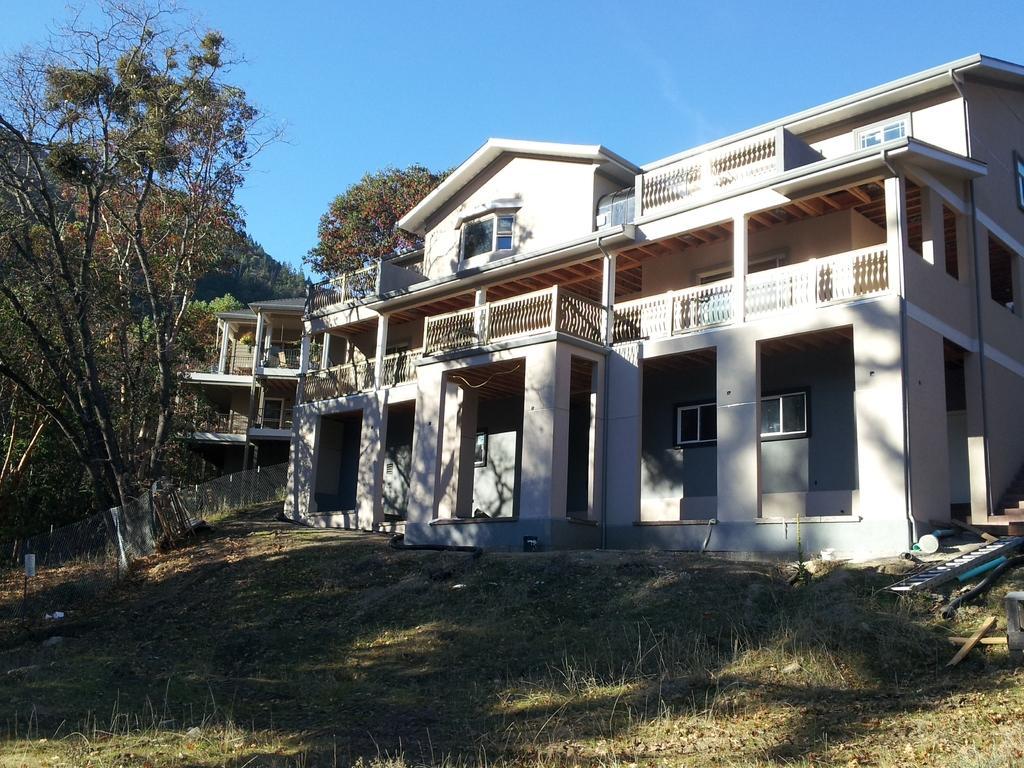Please provide a concise description of this image. In this picture we can see there are buildings and fence. On the left side of the image, there are trees. Behind the buildings, there is the sky. On the right side of the image, there is a ladder and some objects. At the bottom of the image, there is grass. 